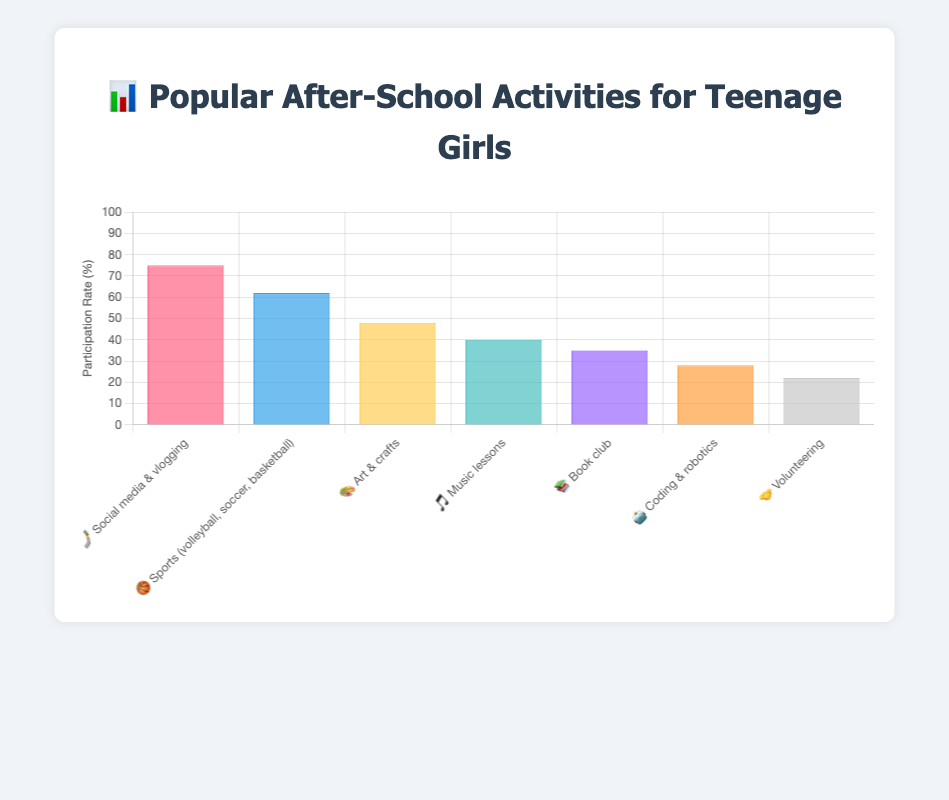What's the title of the figure? The title is prominent and positioned at the top center of the figure, providing a summary of the chart's content. It reads "📊 Popular After-School Activities for Teenage Girls."
Answer: 📊 Popular After-School Activities for Teenage Girls How many different after-school activities are depicted? By counting the bars on the chart or referring to the data labels, one can determine the total number of activities included. There are 7 different activities depicted.
Answer: 7 Which after-school activity has the highest participation rate? Looking at the tallest bar in the chart, which represents the highest value on the y-axis, Social media & vlogging (🏞🤳) has the highest participation rate at 75%.
Answer: Social media & vlogging (🏞🤳) Which activity has the lowest participation rate and what is that rate? The shortest bar corresponds to the lowest participation rate. Volunteering (🤝) has the lowest rate at 22%.
Answer: Volunteering, 22% What is the participation rate difference between Sports and Book club activities? From the chart, Sports (🏀) has a participation rate of 62%, and Book club (📚) has 35%. The difference is calculated as 62% - 35% = 27%.
Answer: 27% Arrange the activities from highest to lowest participation rate. Referring to the heights of the bars or the corresponding data values in the chart, the activities sorted are as follows: Social media & vlogging (🀄🤳), Sports (🏀), Art & crafts (🎨), Music lessons (🎵), Book club (📚), Coding & robotics (🤖), Volunteering (🥰🤝).
Answer: Social media & vlogging, Sports, Art & crafts, Music lessons, Book club, Coding & robotics, Volunteering What is the total participation rate when combining Music lessons and Coding & robotics? The participation rates for Music lessons (🎵) and Coding & robotics (🤖) are 40% and 28%, respectively. Adding these rates gives 40% + 28% = 68%.
Answer: 68% Is the participation rate for Art & crafts higher or lower than the average participation rate of all activities? First calculate the average participation rate for all activities: (75% + 62% + 48% + 40% + 35% + 28% + 22%) / 7 = 44.29%. The participation rate for Art & crafts (🎨) is 48%, which is higher than the average (44.29%).
Answer: Higher What is the range of participation rates across the activities? The range is calculated by subtracting the lowest participation rate from the highest. For these activities, the highest is 75% (Social media & vlogging 🤳), and the lowest is 22% (Volunteering 🤝). So, the range is 75% - 22% = 53%.
Answer: 53% Which activities have a participation rate above 50%? Examining the chart, the activities above 50% are: Social media & vlogging (🤳) with 75%, and Sports (🏀) with 62%.
Answer: Social media & vlogging, Sports 